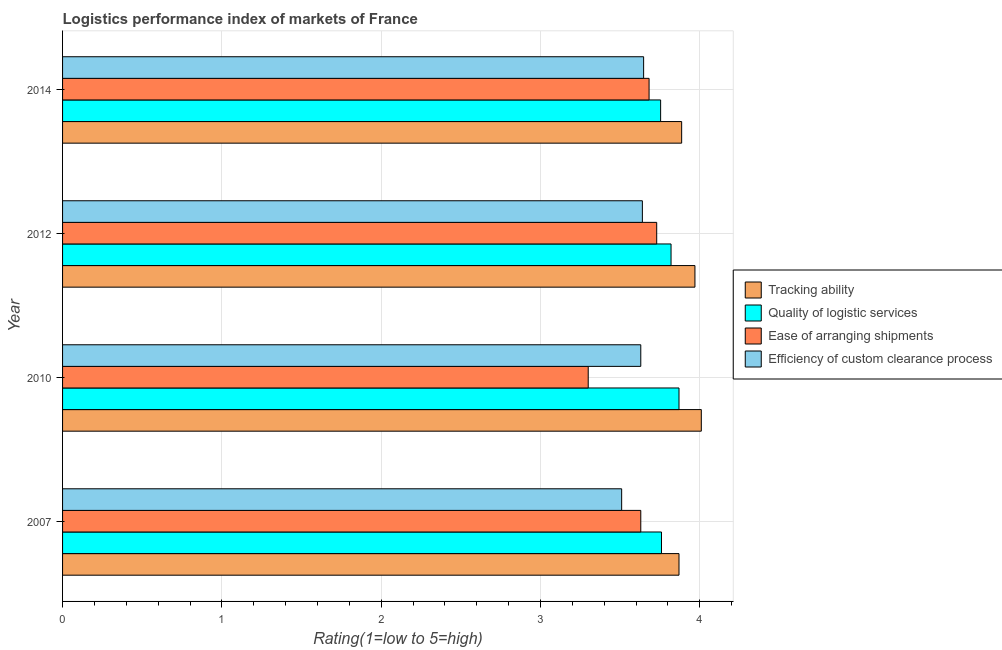How many different coloured bars are there?
Offer a very short reply. 4. Are the number of bars on each tick of the Y-axis equal?
Your response must be concise. Yes. What is the label of the 2nd group of bars from the top?
Give a very brief answer. 2012. What is the lpi rating of tracking ability in 2010?
Offer a very short reply. 4.01. Across all years, what is the maximum lpi rating of efficiency of custom clearance process?
Your answer should be very brief. 3.65. Across all years, what is the minimum lpi rating of efficiency of custom clearance process?
Your answer should be compact. 3.51. In which year was the lpi rating of ease of arranging shipments maximum?
Ensure brevity in your answer.  2012. In which year was the lpi rating of efficiency of custom clearance process minimum?
Offer a terse response. 2007. What is the total lpi rating of quality of logistic services in the graph?
Your answer should be compact. 15.2. What is the difference between the lpi rating of efficiency of custom clearance process in 2010 and that in 2014?
Provide a succinct answer. -0.02. What is the difference between the lpi rating of quality of logistic services in 2010 and the lpi rating of ease of arranging shipments in 2014?
Ensure brevity in your answer.  0.19. What is the average lpi rating of ease of arranging shipments per year?
Your answer should be very brief. 3.59. In the year 2014, what is the difference between the lpi rating of quality of logistic services and lpi rating of ease of arranging shipments?
Your response must be concise. 0.07. Is the lpi rating of efficiency of custom clearance process in 2010 less than that in 2012?
Your response must be concise. Yes. Is the difference between the lpi rating of tracking ability in 2007 and 2014 greater than the difference between the lpi rating of ease of arranging shipments in 2007 and 2014?
Give a very brief answer. Yes. What is the difference between the highest and the lowest lpi rating of ease of arranging shipments?
Ensure brevity in your answer.  0.43. What does the 4th bar from the top in 2010 represents?
Provide a succinct answer. Tracking ability. What does the 4th bar from the bottom in 2007 represents?
Give a very brief answer. Efficiency of custom clearance process. Is it the case that in every year, the sum of the lpi rating of tracking ability and lpi rating of quality of logistic services is greater than the lpi rating of ease of arranging shipments?
Make the answer very short. Yes. What is the difference between two consecutive major ticks on the X-axis?
Your answer should be compact. 1. Does the graph contain any zero values?
Your answer should be compact. No. Does the graph contain grids?
Provide a short and direct response. Yes. Where does the legend appear in the graph?
Give a very brief answer. Center right. What is the title of the graph?
Provide a succinct answer. Logistics performance index of markets of France. What is the label or title of the X-axis?
Your response must be concise. Rating(1=low to 5=high). What is the label or title of the Y-axis?
Your answer should be very brief. Year. What is the Rating(1=low to 5=high) of Tracking ability in 2007?
Offer a very short reply. 3.87. What is the Rating(1=low to 5=high) in Quality of logistic services in 2007?
Ensure brevity in your answer.  3.76. What is the Rating(1=low to 5=high) in Ease of arranging shipments in 2007?
Keep it short and to the point. 3.63. What is the Rating(1=low to 5=high) in Efficiency of custom clearance process in 2007?
Keep it short and to the point. 3.51. What is the Rating(1=low to 5=high) of Tracking ability in 2010?
Ensure brevity in your answer.  4.01. What is the Rating(1=low to 5=high) of Quality of logistic services in 2010?
Keep it short and to the point. 3.87. What is the Rating(1=low to 5=high) of Efficiency of custom clearance process in 2010?
Your response must be concise. 3.63. What is the Rating(1=low to 5=high) of Tracking ability in 2012?
Keep it short and to the point. 3.97. What is the Rating(1=low to 5=high) in Quality of logistic services in 2012?
Your answer should be compact. 3.82. What is the Rating(1=low to 5=high) of Ease of arranging shipments in 2012?
Offer a terse response. 3.73. What is the Rating(1=low to 5=high) in Efficiency of custom clearance process in 2012?
Provide a short and direct response. 3.64. What is the Rating(1=low to 5=high) of Tracking ability in 2014?
Give a very brief answer. 3.89. What is the Rating(1=low to 5=high) in Quality of logistic services in 2014?
Give a very brief answer. 3.75. What is the Rating(1=low to 5=high) in Ease of arranging shipments in 2014?
Provide a succinct answer. 3.68. What is the Rating(1=low to 5=high) of Efficiency of custom clearance process in 2014?
Keep it short and to the point. 3.65. Across all years, what is the maximum Rating(1=low to 5=high) in Tracking ability?
Ensure brevity in your answer.  4.01. Across all years, what is the maximum Rating(1=low to 5=high) in Quality of logistic services?
Ensure brevity in your answer.  3.87. Across all years, what is the maximum Rating(1=low to 5=high) in Ease of arranging shipments?
Ensure brevity in your answer.  3.73. Across all years, what is the maximum Rating(1=low to 5=high) in Efficiency of custom clearance process?
Provide a succinct answer. 3.65. Across all years, what is the minimum Rating(1=low to 5=high) of Tracking ability?
Provide a succinct answer. 3.87. Across all years, what is the minimum Rating(1=low to 5=high) in Quality of logistic services?
Give a very brief answer. 3.75. Across all years, what is the minimum Rating(1=low to 5=high) of Efficiency of custom clearance process?
Make the answer very short. 3.51. What is the total Rating(1=low to 5=high) of Tracking ability in the graph?
Ensure brevity in your answer.  15.74. What is the total Rating(1=low to 5=high) of Quality of logistic services in the graph?
Provide a short and direct response. 15.2. What is the total Rating(1=low to 5=high) of Ease of arranging shipments in the graph?
Your response must be concise. 14.34. What is the total Rating(1=low to 5=high) of Efficiency of custom clearance process in the graph?
Offer a terse response. 14.43. What is the difference between the Rating(1=low to 5=high) in Tracking ability in 2007 and that in 2010?
Give a very brief answer. -0.14. What is the difference between the Rating(1=low to 5=high) of Quality of logistic services in 2007 and that in 2010?
Your answer should be compact. -0.11. What is the difference between the Rating(1=low to 5=high) of Ease of arranging shipments in 2007 and that in 2010?
Offer a terse response. 0.33. What is the difference between the Rating(1=low to 5=high) of Efficiency of custom clearance process in 2007 and that in 2010?
Provide a short and direct response. -0.12. What is the difference between the Rating(1=low to 5=high) of Tracking ability in 2007 and that in 2012?
Give a very brief answer. -0.1. What is the difference between the Rating(1=low to 5=high) in Quality of logistic services in 2007 and that in 2012?
Provide a short and direct response. -0.06. What is the difference between the Rating(1=low to 5=high) in Ease of arranging shipments in 2007 and that in 2012?
Ensure brevity in your answer.  -0.1. What is the difference between the Rating(1=low to 5=high) of Efficiency of custom clearance process in 2007 and that in 2012?
Your answer should be very brief. -0.13. What is the difference between the Rating(1=low to 5=high) of Tracking ability in 2007 and that in 2014?
Make the answer very short. -0.02. What is the difference between the Rating(1=low to 5=high) in Quality of logistic services in 2007 and that in 2014?
Your answer should be compact. 0.01. What is the difference between the Rating(1=low to 5=high) in Ease of arranging shipments in 2007 and that in 2014?
Provide a short and direct response. -0.05. What is the difference between the Rating(1=low to 5=high) in Efficiency of custom clearance process in 2007 and that in 2014?
Your answer should be compact. -0.14. What is the difference between the Rating(1=low to 5=high) of Tracking ability in 2010 and that in 2012?
Provide a short and direct response. 0.04. What is the difference between the Rating(1=low to 5=high) in Quality of logistic services in 2010 and that in 2012?
Make the answer very short. 0.05. What is the difference between the Rating(1=low to 5=high) in Ease of arranging shipments in 2010 and that in 2012?
Provide a short and direct response. -0.43. What is the difference between the Rating(1=low to 5=high) of Efficiency of custom clearance process in 2010 and that in 2012?
Your response must be concise. -0.01. What is the difference between the Rating(1=low to 5=high) in Tracking ability in 2010 and that in 2014?
Offer a very short reply. 0.12. What is the difference between the Rating(1=low to 5=high) of Quality of logistic services in 2010 and that in 2014?
Ensure brevity in your answer.  0.12. What is the difference between the Rating(1=low to 5=high) of Ease of arranging shipments in 2010 and that in 2014?
Your answer should be very brief. -0.38. What is the difference between the Rating(1=low to 5=high) in Efficiency of custom clearance process in 2010 and that in 2014?
Offer a terse response. -0.02. What is the difference between the Rating(1=low to 5=high) of Tracking ability in 2012 and that in 2014?
Offer a very short reply. 0.08. What is the difference between the Rating(1=low to 5=high) of Quality of logistic services in 2012 and that in 2014?
Offer a very short reply. 0.07. What is the difference between the Rating(1=low to 5=high) in Ease of arranging shipments in 2012 and that in 2014?
Your response must be concise. 0.05. What is the difference between the Rating(1=low to 5=high) of Efficiency of custom clearance process in 2012 and that in 2014?
Offer a very short reply. -0.01. What is the difference between the Rating(1=low to 5=high) in Tracking ability in 2007 and the Rating(1=low to 5=high) in Ease of arranging shipments in 2010?
Your answer should be very brief. 0.57. What is the difference between the Rating(1=low to 5=high) in Tracking ability in 2007 and the Rating(1=low to 5=high) in Efficiency of custom clearance process in 2010?
Offer a terse response. 0.24. What is the difference between the Rating(1=low to 5=high) of Quality of logistic services in 2007 and the Rating(1=low to 5=high) of Ease of arranging shipments in 2010?
Provide a succinct answer. 0.46. What is the difference between the Rating(1=low to 5=high) in Quality of logistic services in 2007 and the Rating(1=low to 5=high) in Efficiency of custom clearance process in 2010?
Your response must be concise. 0.13. What is the difference between the Rating(1=low to 5=high) in Tracking ability in 2007 and the Rating(1=low to 5=high) in Quality of logistic services in 2012?
Make the answer very short. 0.05. What is the difference between the Rating(1=low to 5=high) of Tracking ability in 2007 and the Rating(1=low to 5=high) of Ease of arranging shipments in 2012?
Provide a succinct answer. 0.14. What is the difference between the Rating(1=low to 5=high) of Tracking ability in 2007 and the Rating(1=low to 5=high) of Efficiency of custom clearance process in 2012?
Ensure brevity in your answer.  0.23. What is the difference between the Rating(1=low to 5=high) of Quality of logistic services in 2007 and the Rating(1=low to 5=high) of Ease of arranging shipments in 2012?
Give a very brief answer. 0.03. What is the difference between the Rating(1=low to 5=high) of Quality of logistic services in 2007 and the Rating(1=low to 5=high) of Efficiency of custom clearance process in 2012?
Your answer should be very brief. 0.12. What is the difference between the Rating(1=low to 5=high) of Ease of arranging shipments in 2007 and the Rating(1=low to 5=high) of Efficiency of custom clearance process in 2012?
Give a very brief answer. -0.01. What is the difference between the Rating(1=low to 5=high) of Tracking ability in 2007 and the Rating(1=low to 5=high) of Quality of logistic services in 2014?
Give a very brief answer. 0.12. What is the difference between the Rating(1=low to 5=high) in Tracking ability in 2007 and the Rating(1=low to 5=high) in Ease of arranging shipments in 2014?
Provide a succinct answer. 0.19. What is the difference between the Rating(1=low to 5=high) in Tracking ability in 2007 and the Rating(1=low to 5=high) in Efficiency of custom clearance process in 2014?
Provide a short and direct response. 0.22. What is the difference between the Rating(1=low to 5=high) of Quality of logistic services in 2007 and the Rating(1=low to 5=high) of Ease of arranging shipments in 2014?
Ensure brevity in your answer.  0.08. What is the difference between the Rating(1=low to 5=high) in Quality of logistic services in 2007 and the Rating(1=low to 5=high) in Efficiency of custom clearance process in 2014?
Offer a terse response. 0.11. What is the difference between the Rating(1=low to 5=high) in Ease of arranging shipments in 2007 and the Rating(1=low to 5=high) in Efficiency of custom clearance process in 2014?
Your answer should be compact. -0.02. What is the difference between the Rating(1=low to 5=high) in Tracking ability in 2010 and the Rating(1=low to 5=high) in Quality of logistic services in 2012?
Ensure brevity in your answer.  0.19. What is the difference between the Rating(1=low to 5=high) in Tracking ability in 2010 and the Rating(1=low to 5=high) in Ease of arranging shipments in 2012?
Give a very brief answer. 0.28. What is the difference between the Rating(1=low to 5=high) of Tracking ability in 2010 and the Rating(1=low to 5=high) of Efficiency of custom clearance process in 2012?
Give a very brief answer. 0.37. What is the difference between the Rating(1=low to 5=high) in Quality of logistic services in 2010 and the Rating(1=low to 5=high) in Ease of arranging shipments in 2012?
Your answer should be compact. 0.14. What is the difference between the Rating(1=low to 5=high) of Quality of logistic services in 2010 and the Rating(1=low to 5=high) of Efficiency of custom clearance process in 2012?
Your answer should be compact. 0.23. What is the difference between the Rating(1=low to 5=high) in Ease of arranging shipments in 2010 and the Rating(1=low to 5=high) in Efficiency of custom clearance process in 2012?
Offer a very short reply. -0.34. What is the difference between the Rating(1=low to 5=high) in Tracking ability in 2010 and the Rating(1=low to 5=high) in Quality of logistic services in 2014?
Make the answer very short. 0.26. What is the difference between the Rating(1=low to 5=high) in Tracking ability in 2010 and the Rating(1=low to 5=high) in Ease of arranging shipments in 2014?
Give a very brief answer. 0.33. What is the difference between the Rating(1=low to 5=high) in Tracking ability in 2010 and the Rating(1=low to 5=high) in Efficiency of custom clearance process in 2014?
Offer a terse response. 0.36. What is the difference between the Rating(1=low to 5=high) in Quality of logistic services in 2010 and the Rating(1=low to 5=high) in Ease of arranging shipments in 2014?
Ensure brevity in your answer.  0.19. What is the difference between the Rating(1=low to 5=high) in Quality of logistic services in 2010 and the Rating(1=low to 5=high) in Efficiency of custom clearance process in 2014?
Ensure brevity in your answer.  0.22. What is the difference between the Rating(1=low to 5=high) in Ease of arranging shipments in 2010 and the Rating(1=low to 5=high) in Efficiency of custom clearance process in 2014?
Make the answer very short. -0.35. What is the difference between the Rating(1=low to 5=high) in Tracking ability in 2012 and the Rating(1=low to 5=high) in Quality of logistic services in 2014?
Your answer should be very brief. 0.22. What is the difference between the Rating(1=low to 5=high) of Tracking ability in 2012 and the Rating(1=low to 5=high) of Ease of arranging shipments in 2014?
Provide a short and direct response. 0.29. What is the difference between the Rating(1=low to 5=high) in Tracking ability in 2012 and the Rating(1=low to 5=high) in Efficiency of custom clearance process in 2014?
Provide a short and direct response. 0.32. What is the difference between the Rating(1=low to 5=high) in Quality of logistic services in 2012 and the Rating(1=low to 5=high) in Ease of arranging shipments in 2014?
Ensure brevity in your answer.  0.14. What is the difference between the Rating(1=low to 5=high) of Quality of logistic services in 2012 and the Rating(1=low to 5=high) of Efficiency of custom clearance process in 2014?
Keep it short and to the point. 0.17. What is the difference between the Rating(1=low to 5=high) in Ease of arranging shipments in 2012 and the Rating(1=low to 5=high) in Efficiency of custom clearance process in 2014?
Give a very brief answer. 0.08. What is the average Rating(1=low to 5=high) in Tracking ability per year?
Provide a succinct answer. 3.93. What is the average Rating(1=low to 5=high) in Quality of logistic services per year?
Provide a short and direct response. 3.8. What is the average Rating(1=low to 5=high) in Ease of arranging shipments per year?
Keep it short and to the point. 3.59. What is the average Rating(1=low to 5=high) in Efficiency of custom clearance process per year?
Make the answer very short. 3.61. In the year 2007, what is the difference between the Rating(1=low to 5=high) of Tracking ability and Rating(1=low to 5=high) of Quality of logistic services?
Offer a terse response. 0.11. In the year 2007, what is the difference between the Rating(1=low to 5=high) of Tracking ability and Rating(1=low to 5=high) of Ease of arranging shipments?
Offer a terse response. 0.24. In the year 2007, what is the difference between the Rating(1=low to 5=high) in Tracking ability and Rating(1=low to 5=high) in Efficiency of custom clearance process?
Provide a short and direct response. 0.36. In the year 2007, what is the difference between the Rating(1=low to 5=high) of Quality of logistic services and Rating(1=low to 5=high) of Ease of arranging shipments?
Offer a very short reply. 0.13. In the year 2007, what is the difference between the Rating(1=low to 5=high) in Quality of logistic services and Rating(1=low to 5=high) in Efficiency of custom clearance process?
Ensure brevity in your answer.  0.25. In the year 2007, what is the difference between the Rating(1=low to 5=high) in Ease of arranging shipments and Rating(1=low to 5=high) in Efficiency of custom clearance process?
Provide a succinct answer. 0.12. In the year 2010, what is the difference between the Rating(1=low to 5=high) of Tracking ability and Rating(1=low to 5=high) of Quality of logistic services?
Your answer should be compact. 0.14. In the year 2010, what is the difference between the Rating(1=low to 5=high) in Tracking ability and Rating(1=low to 5=high) in Ease of arranging shipments?
Keep it short and to the point. 0.71. In the year 2010, what is the difference between the Rating(1=low to 5=high) in Tracking ability and Rating(1=low to 5=high) in Efficiency of custom clearance process?
Your answer should be very brief. 0.38. In the year 2010, what is the difference between the Rating(1=low to 5=high) in Quality of logistic services and Rating(1=low to 5=high) in Ease of arranging shipments?
Your answer should be very brief. 0.57. In the year 2010, what is the difference between the Rating(1=low to 5=high) in Quality of logistic services and Rating(1=low to 5=high) in Efficiency of custom clearance process?
Your answer should be very brief. 0.24. In the year 2010, what is the difference between the Rating(1=low to 5=high) in Ease of arranging shipments and Rating(1=low to 5=high) in Efficiency of custom clearance process?
Your response must be concise. -0.33. In the year 2012, what is the difference between the Rating(1=low to 5=high) of Tracking ability and Rating(1=low to 5=high) of Ease of arranging shipments?
Provide a succinct answer. 0.24. In the year 2012, what is the difference between the Rating(1=low to 5=high) of Tracking ability and Rating(1=low to 5=high) of Efficiency of custom clearance process?
Give a very brief answer. 0.33. In the year 2012, what is the difference between the Rating(1=low to 5=high) of Quality of logistic services and Rating(1=low to 5=high) of Ease of arranging shipments?
Make the answer very short. 0.09. In the year 2012, what is the difference between the Rating(1=low to 5=high) of Quality of logistic services and Rating(1=low to 5=high) of Efficiency of custom clearance process?
Provide a succinct answer. 0.18. In the year 2012, what is the difference between the Rating(1=low to 5=high) in Ease of arranging shipments and Rating(1=low to 5=high) in Efficiency of custom clearance process?
Ensure brevity in your answer.  0.09. In the year 2014, what is the difference between the Rating(1=low to 5=high) in Tracking ability and Rating(1=low to 5=high) in Quality of logistic services?
Ensure brevity in your answer.  0.13. In the year 2014, what is the difference between the Rating(1=low to 5=high) of Tracking ability and Rating(1=low to 5=high) of Ease of arranging shipments?
Ensure brevity in your answer.  0.2. In the year 2014, what is the difference between the Rating(1=low to 5=high) of Tracking ability and Rating(1=low to 5=high) of Efficiency of custom clearance process?
Provide a short and direct response. 0.24. In the year 2014, what is the difference between the Rating(1=low to 5=high) of Quality of logistic services and Rating(1=low to 5=high) of Ease of arranging shipments?
Ensure brevity in your answer.  0.07. In the year 2014, what is the difference between the Rating(1=low to 5=high) in Quality of logistic services and Rating(1=low to 5=high) in Efficiency of custom clearance process?
Make the answer very short. 0.11. In the year 2014, what is the difference between the Rating(1=low to 5=high) in Ease of arranging shipments and Rating(1=low to 5=high) in Efficiency of custom clearance process?
Offer a very short reply. 0.03. What is the ratio of the Rating(1=low to 5=high) in Tracking ability in 2007 to that in 2010?
Give a very brief answer. 0.97. What is the ratio of the Rating(1=low to 5=high) of Quality of logistic services in 2007 to that in 2010?
Ensure brevity in your answer.  0.97. What is the ratio of the Rating(1=low to 5=high) of Ease of arranging shipments in 2007 to that in 2010?
Offer a very short reply. 1.1. What is the ratio of the Rating(1=low to 5=high) of Efficiency of custom clearance process in 2007 to that in 2010?
Offer a very short reply. 0.97. What is the ratio of the Rating(1=low to 5=high) of Tracking ability in 2007 to that in 2012?
Keep it short and to the point. 0.97. What is the ratio of the Rating(1=low to 5=high) of Quality of logistic services in 2007 to that in 2012?
Your answer should be very brief. 0.98. What is the ratio of the Rating(1=low to 5=high) in Ease of arranging shipments in 2007 to that in 2012?
Offer a terse response. 0.97. What is the ratio of the Rating(1=low to 5=high) of Ease of arranging shipments in 2007 to that in 2014?
Ensure brevity in your answer.  0.99. What is the ratio of the Rating(1=low to 5=high) in Efficiency of custom clearance process in 2007 to that in 2014?
Make the answer very short. 0.96. What is the ratio of the Rating(1=low to 5=high) in Tracking ability in 2010 to that in 2012?
Provide a succinct answer. 1.01. What is the ratio of the Rating(1=low to 5=high) in Quality of logistic services in 2010 to that in 2012?
Your response must be concise. 1.01. What is the ratio of the Rating(1=low to 5=high) of Ease of arranging shipments in 2010 to that in 2012?
Offer a very short reply. 0.88. What is the ratio of the Rating(1=low to 5=high) of Tracking ability in 2010 to that in 2014?
Offer a very short reply. 1.03. What is the ratio of the Rating(1=low to 5=high) in Quality of logistic services in 2010 to that in 2014?
Make the answer very short. 1.03. What is the ratio of the Rating(1=low to 5=high) of Ease of arranging shipments in 2010 to that in 2014?
Ensure brevity in your answer.  0.9. What is the ratio of the Rating(1=low to 5=high) of Tracking ability in 2012 to that in 2014?
Provide a succinct answer. 1.02. What is the ratio of the Rating(1=low to 5=high) of Quality of logistic services in 2012 to that in 2014?
Provide a short and direct response. 1.02. What is the ratio of the Rating(1=low to 5=high) of Ease of arranging shipments in 2012 to that in 2014?
Your answer should be compact. 1.01. What is the ratio of the Rating(1=low to 5=high) of Efficiency of custom clearance process in 2012 to that in 2014?
Provide a succinct answer. 1. What is the difference between the highest and the second highest Rating(1=low to 5=high) in Quality of logistic services?
Offer a very short reply. 0.05. What is the difference between the highest and the second highest Rating(1=low to 5=high) of Ease of arranging shipments?
Your answer should be compact. 0.05. What is the difference between the highest and the second highest Rating(1=low to 5=high) in Efficiency of custom clearance process?
Offer a terse response. 0.01. What is the difference between the highest and the lowest Rating(1=low to 5=high) of Tracking ability?
Give a very brief answer. 0.14. What is the difference between the highest and the lowest Rating(1=low to 5=high) in Quality of logistic services?
Ensure brevity in your answer.  0.12. What is the difference between the highest and the lowest Rating(1=low to 5=high) in Ease of arranging shipments?
Make the answer very short. 0.43. What is the difference between the highest and the lowest Rating(1=low to 5=high) of Efficiency of custom clearance process?
Ensure brevity in your answer.  0.14. 